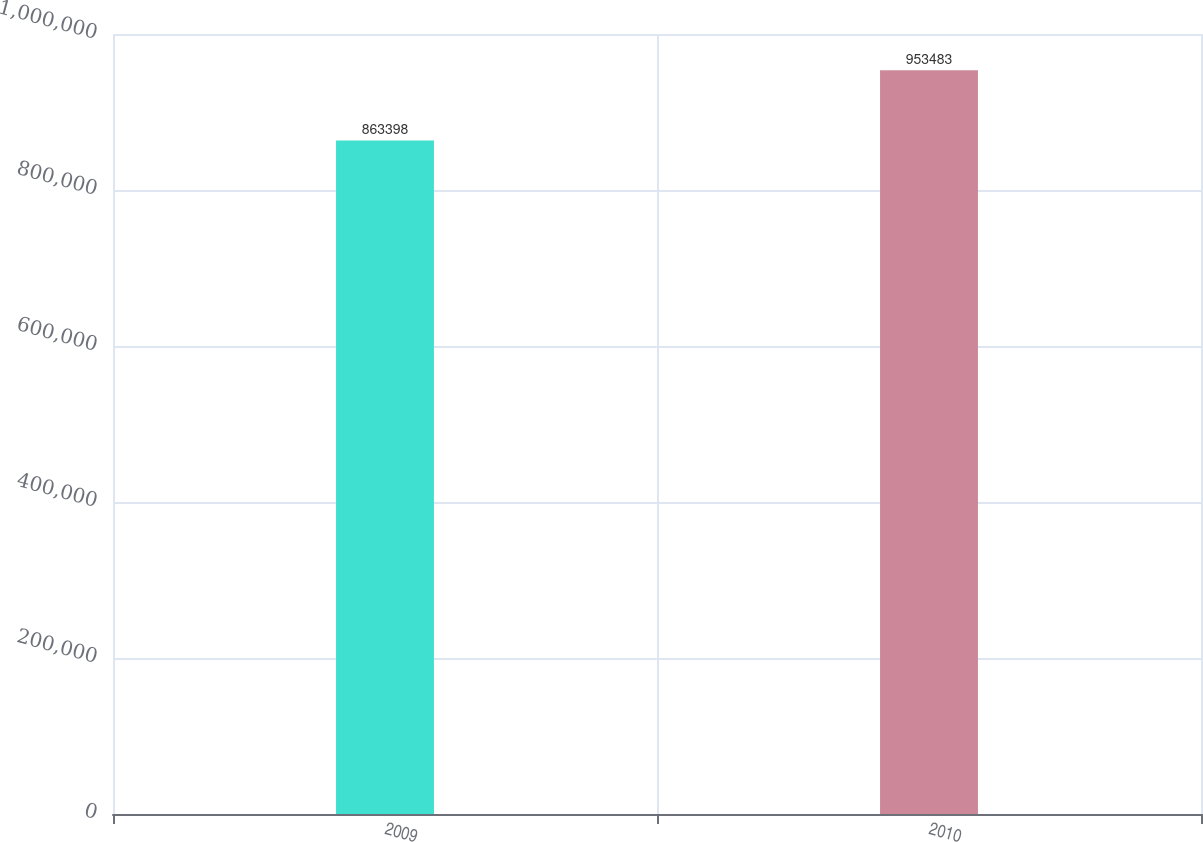Convert chart. <chart><loc_0><loc_0><loc_500><loc_500><bar_chart><fcel>2009<fcel>2010<nl><fcel>863398<fcel>953483<nl></chart> 